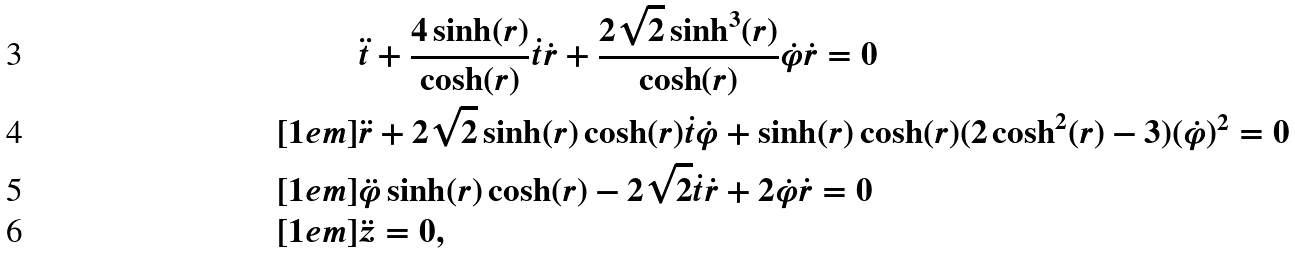Convert formula to latex. <formula><loc_0><loc_0><loc_500><loc_500>& \ddot { t } + \frac { 4 \sinh ( r ) } { \cosh ( r ) } \dot { t } \dot { r } + \frac { 2 \sqrt { 2 } \sinh ^ { 3 } ( r ) } { \cosh ( r ) } \dot { \varphi } \dot { r } = 0 \\ [ 1 e m ] & \ddot { r } + 2 \sqrt { 2 } \sinh ( r ) \cosh ( r ) \dot { t } \dot { \varphi } + \sinh ( r ) \cosh ( r ) ( 2 \cosh ^ { 2 } ( r ) - 3 ) ( \dot { \varphi } ) ^ { 2 } = 0 \\ [ 1 e m ] & \ddot { \varphi } \sinh ( r ) \cosh ( r ) - 2 \sqrt { 2 } \dot { t } \dot { r } + 2 \dot { \varphi } \dot { r } = 0 \\ [ 1 e m ] & \ddot { z } = 0 ,</formula> 